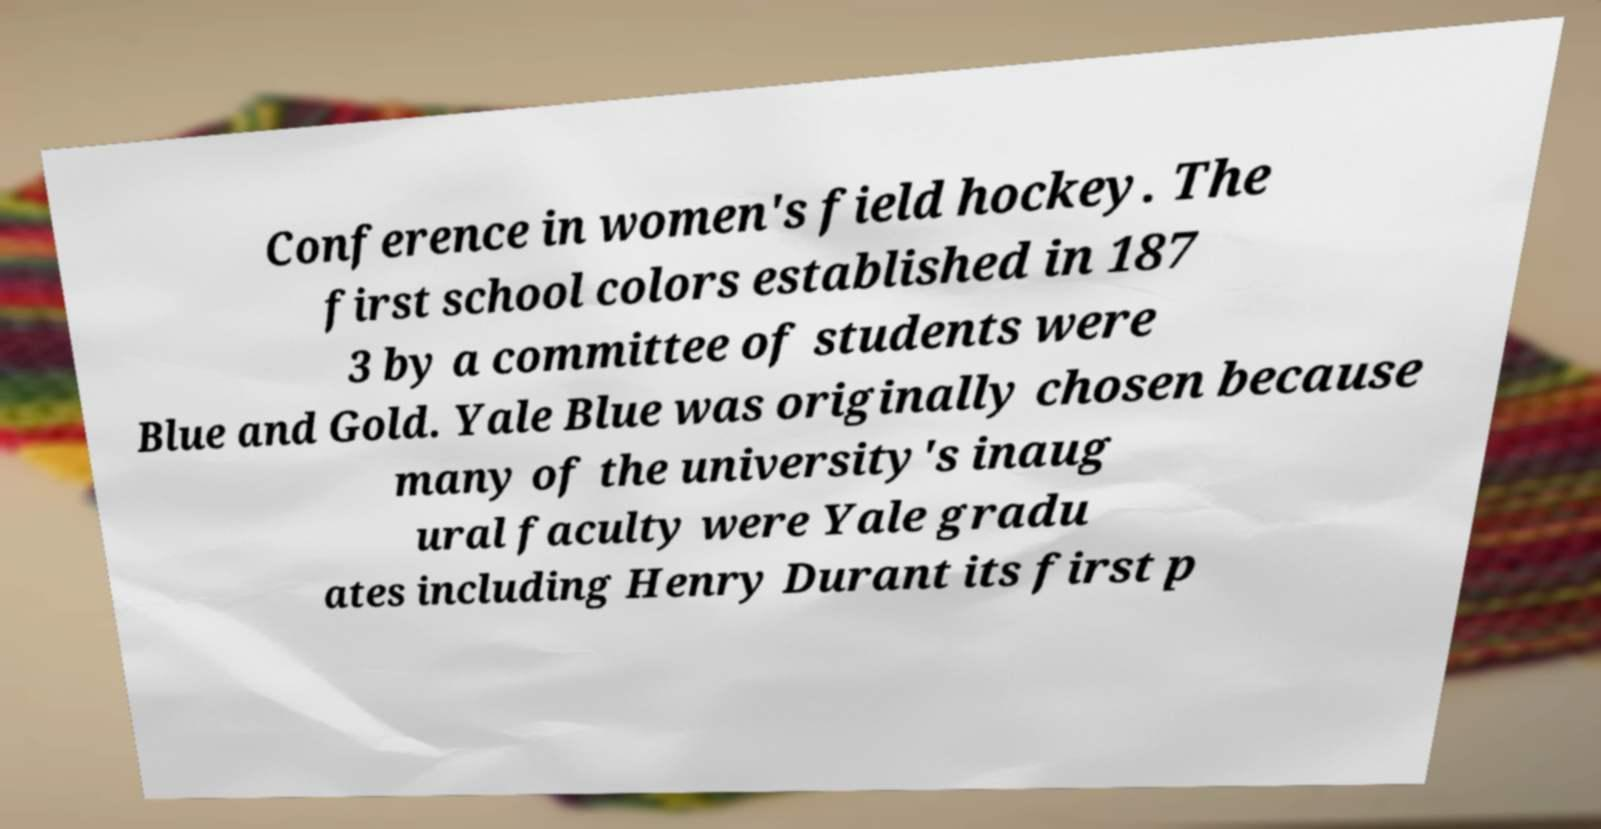Could you assist in decoding the text presented in this image and type it out clearly? Conference in women's field hockey. The first school colors established in 187 3 by a committee of students were Blue and Gold. Yale Blue was originally chosen because many of the university's inaug ural faculty were Yale gradu ates including Henry Durant its first p 